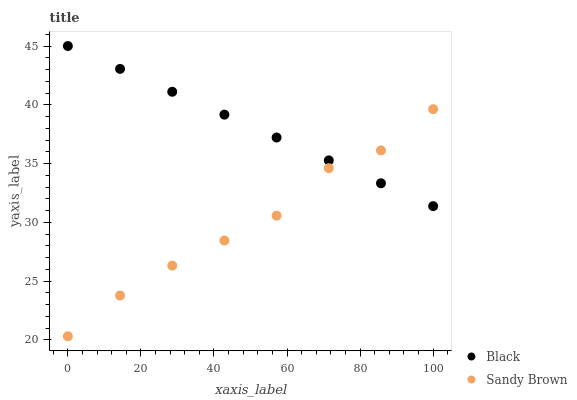Does Sandy Brown have the minimum area under the curve?
Answer yes or no. Yes. Does Black have the maximum area under the curve?
Answer yes or no. Yes. Does Black have the minimum area under the curve?
Answer yes or no. No. Is Black the smoothest?
Answer yes or no. Yes. Is Sandy Brown the roughest?
Answer yes or no. Yes. Is Black the roughest?
Answer yes or no. No. Does Sandy Brown have the lowest value?
Answer yes or no. Yes. Does Black have the lowest value?
Answer yes or no. No. Does Black have the highest value?
Answer yes or no. Yes. Does Black intersect Sandy Brown?
Answer yes or no. Yes. Is Black less than Sandy Brown?
Answer yes or no. No. Is Black greater than Sandy Brown?
Answer yes or no. No. 